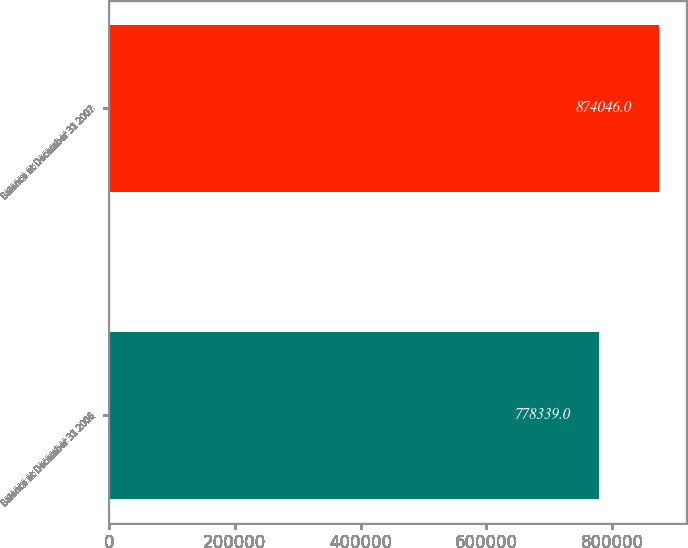Convert chart to OTSL. <chart><loc_0><loc_0><loc_500><loc_500><bar_chart><fcel>Balance at December 31 2006<fcel>Balance at December 31 2007<nl><fcel>778339<fcel>874046<nl></chart> 